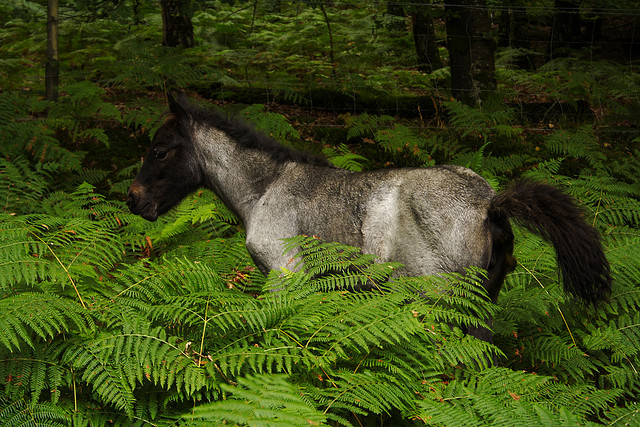<image>What fairy tale does this picture suggest? I don't know what fairy tale the picture suggests, it may suggest 'shrek', 'red riding hood', 'black beauty', 'pin tail on donkey', 'cinderella' or 'hansel and gretel'. What type of plant is shown? I don't know what type of plant is shown, it could be a fern. What type of plant is shown? I am not sure what type of plant is shown. It can be seen fern, green, leaf or horse. What fairy tale does this picture suggest? I don't know what fairy tale this picture suggests. It can be related to 'shrek', 'red riding hood', 'cinderella', 'hansel and gretel', or 'black beauty'. 